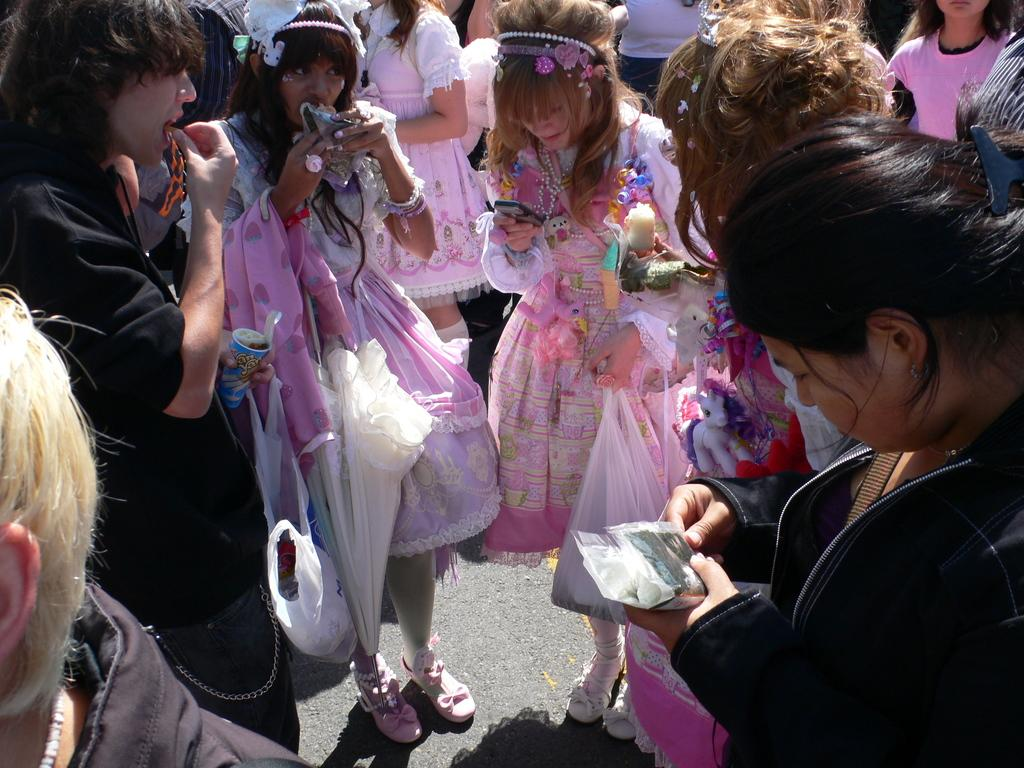How many individuals are present in the image? There are many people in the image. What are the people holding in their hands? The people are holding objects in their hands. What type of goose can be seen producing the objects in the image? There is no goose present in the image, nor is there any indication of objects being produced by any animal. 